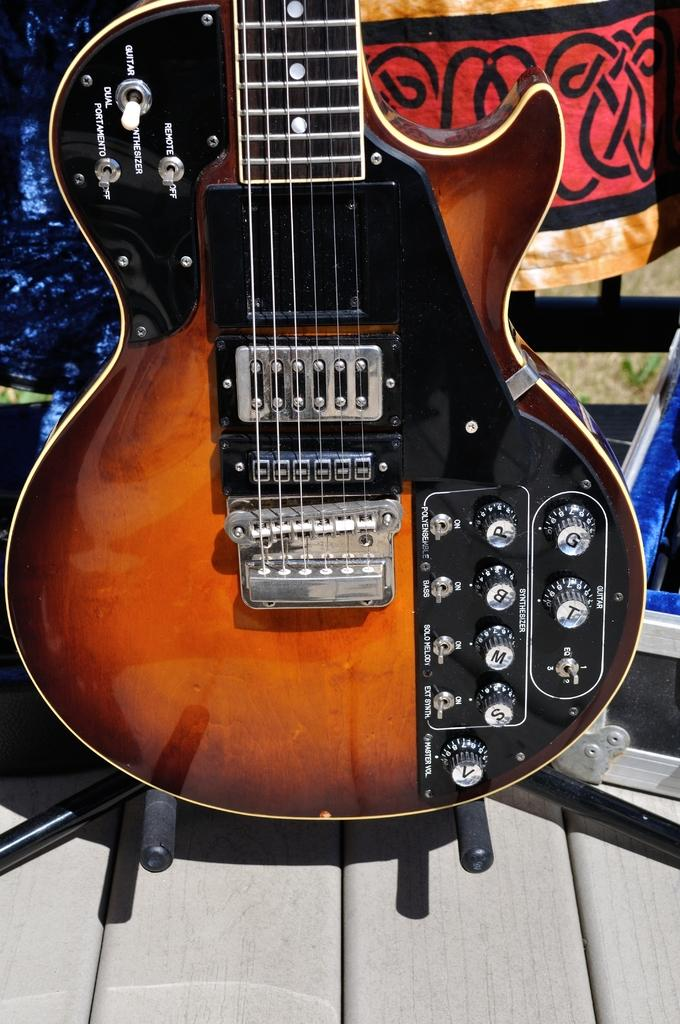What musical instrument is present in the image? There is a guitar in the image. Where is the guitar located? The guitar is on a table. What can be seen in the background of the image? There is a signboard in the background of the image. What type of invention is being demonstrated by the secretary in the image? There is no secretary or invention present in the image; it features a guitar on a table and a signboard in the background. 